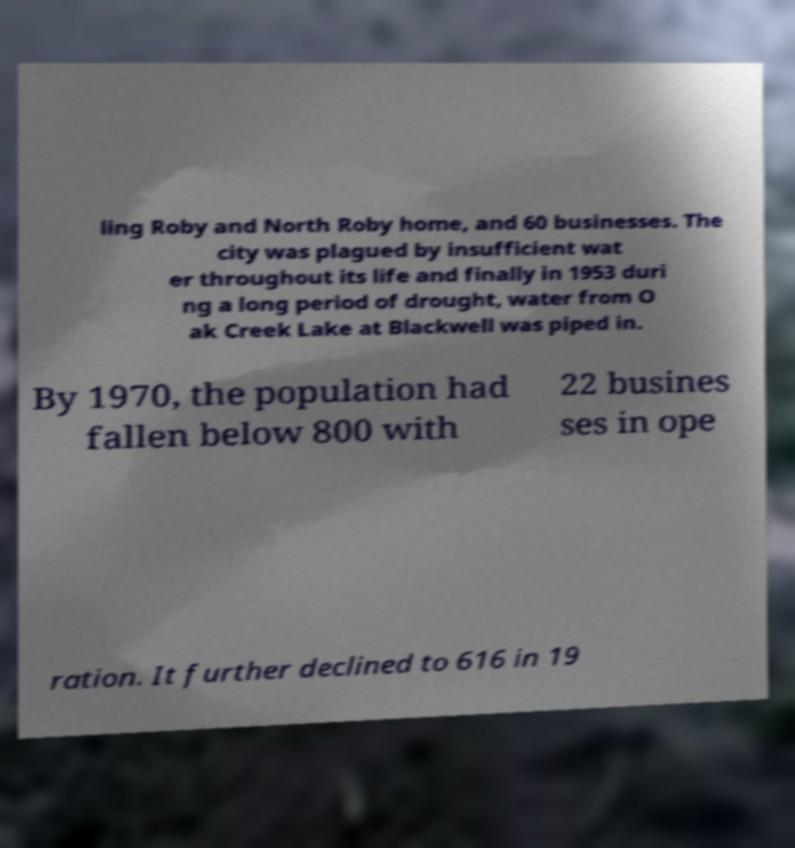Please identify and transcribe the text found in this image. ling Roby and North Roby home, and 60 businesses. The city was plagued by insufficient wat er throughout its life and finally in 1953 duri ng a long period of drought, water from O ak Creek Lake at Blackwell was piped in. By 1970, the population had fallen below 800 with 22 busines ses in ope ration. It further declined to 616 in 19 